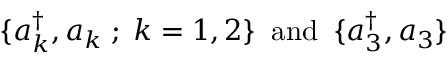Convert formula to latex. <formula><loc_0><loc_0><loc_500><loc_500>\{ a _ { k } ^ { \dagger } , a _ { k } \, ; \, k = 1 , 2 \} \, a n d \, \{ a _ { 3 } ^ { \dagger } , a _ { 3 } \}</formula> 